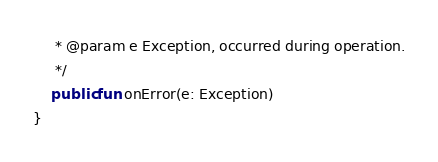<code> <loc_0><loc_0><loc_500><loc_500><_Kotlin_>     * @param e Exception, occurred during operation.
     */
    public fun onError(e: Exception)
}
</code> 